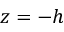Convert formula to latex. <formula><loc_0><loc_0><loc_500><loc_500>z = - h</formula> 